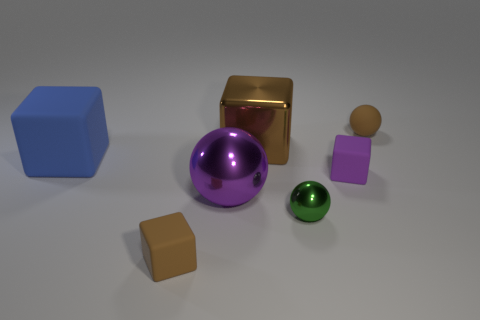There is a small matte object that is behind the blue rubber thing; what is its color?
Ensure brevity in your answer.  Brown. Do the tiny brown object in front of the small matte sphere and the green object have the same material?
Make the answer very short. No. How many big things are both to the left of the brown shiny block and to the right of the big rubber thing?
Provide a succinct answer. 1. What is the color of the block in front of the tiny ball that is in front of the small brown object that is to the right of the green thing?
Ensure brevity in your answer.  Brown. What number of other objects are the same shape as the small purple rubber object?
Keep it short and to the point. 3. Are there any brown blocks that are to the right of the tiny brown thing in front of the tiny matte sphere?
Keep it short and to the point. Yes. What number of matte objects are either tiny purple things or blue objects?
Give a very brief answer. 2. What material is the tiny object that is in front of the big blue rubber block and behind the green metallic ball?
Your answer should be very brief. Rubber. Is there a big purple ball in front of the brown matte thing that is right of the tiny metallic thing right of the large blue matte cube?
Offer a very short reply. Yes. There is a purple thing that is the same material as the small brown cube; what is its shape?
Your answer should be compact. Cube. 